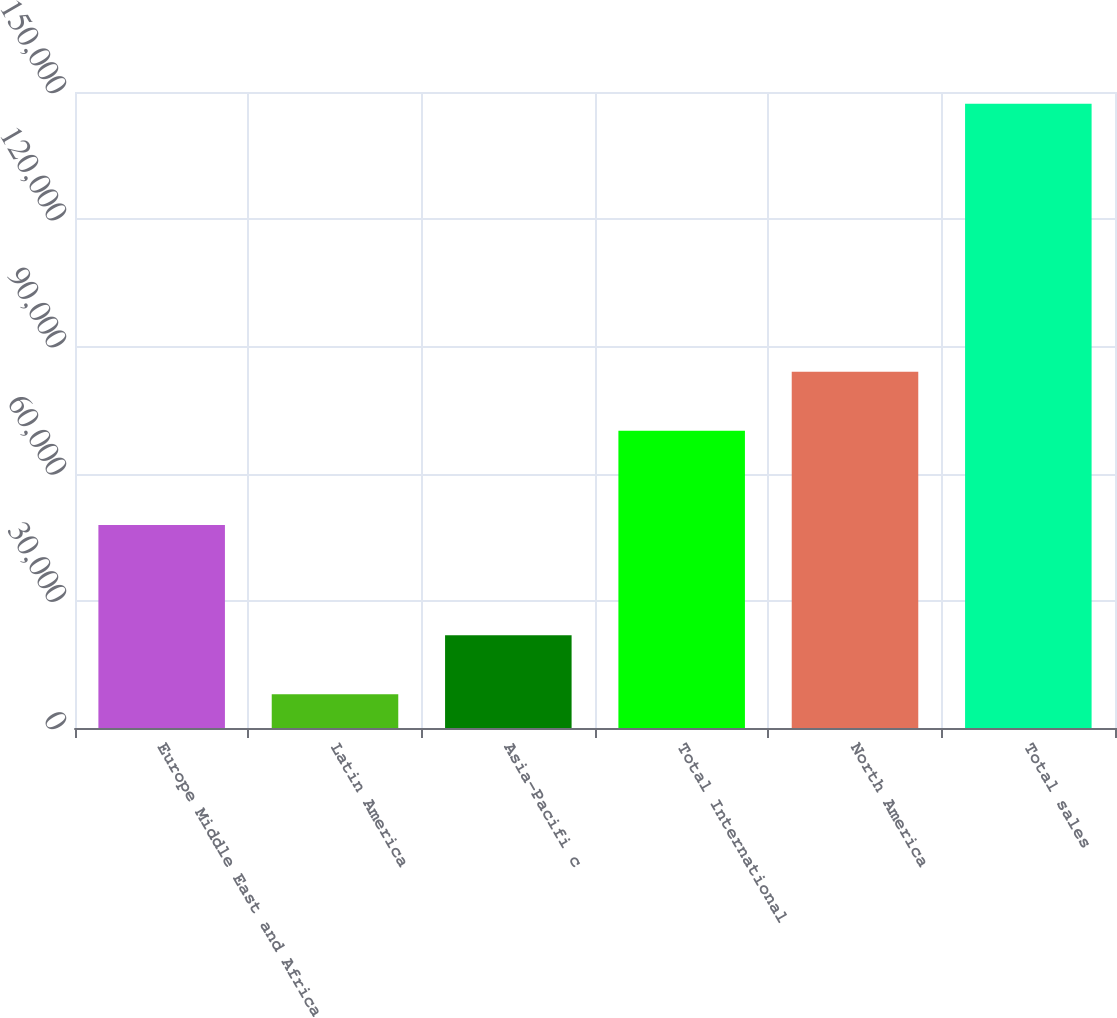Convert chart. <chart><loc_0><loc_0><loc_500><loc_500><bar_chart><fcel>Europe Middle East and Africa<fcel>Latin America<fcel>Asia-Pacifi c<fcel>Total International<fcel>North America<fcel>Total sales<nl><fcel>47893<fcel>7978<fcel>21900.2<fcel>70086<fcel>84008.2<fcel>147200<nl></chart> 